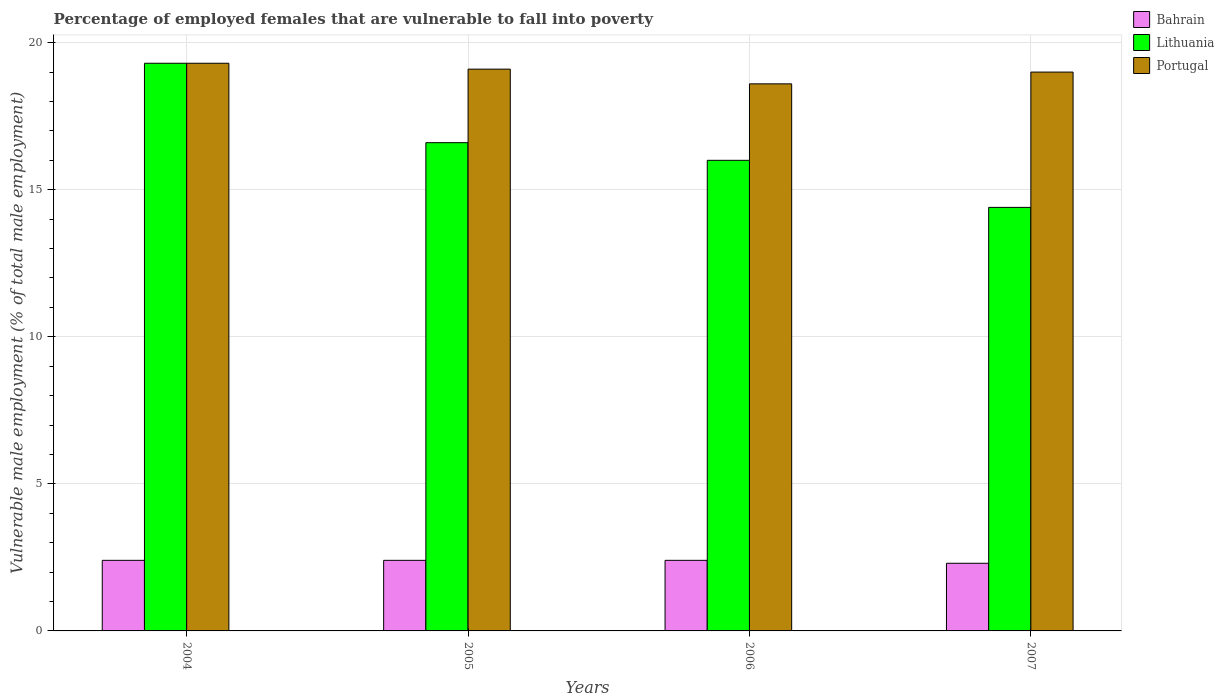How many different coloured bars are there?
Keep it short and to the point. 3. How many groups of bars are there?
Offer a very short reply. 4. Are the number of bars on each tick of the X-axis equal?
Your response must be concise. Yes. How many bars are there on the 2nd tick from the left?
Keep it short and to the point. 3. How many bars are there on the 1st tick from the right?
Provide a short and direct response. 3. What is the label of the 1st group of bars from the left?
Offer a terse response. 2004. In how many cases, is the number of bars for a given year not equal to the number of legend labels?
Your answer should be very brief. 0. What is the percentage of employed females who are vulnerable to fall into poverty in Lithuania in 2004?
Your answer should be compact. 19.3. Across all years, what is the maximum percentage of employed females who are vulnerable to fall into poverty in Lithuania?
Your response must be concise. 19.3. Across all years, what is the minimum percentage of employed females who are vulnerable to fall into poverty in Lithuania?
Ensure brevity in your answer.  14.4. In which year was the percentage of employed females who are vulnerable to fall into poverty in Portugal maximum?
Ensure brevity in your answer.  2004. What is the total percentage of employed females who are vulnerable to fall into poverty in Portugal in the graph?
Your answer should be very brief. 76. What is the difference between the percentage of employed females who are vulnerable to fall into poverty in Portugal in 2005 and that in 2007?
Your answer should be compact. 0.1. What is the difference between the percentage of employed females who are vulnerable to fall into poverty in Portugal in 2007 and the percentage of employed females who are vulnerable to fall into poverty in Lithuania in 2004?
Provide a succinct answer. -0.3. What is the average percentage of employed females who are vulnerable to fall into poverty in Portugal per year?
Ensure brevity in your answer.  19. What is the ratio of the percentage of employed females who are vulnerable to fall into poverty in Bahrain in 2004 to that in 2007?
Provide a succinct answer. 1.04. Is the difference between the percentage of employed females who are vulnerable to fall into poverty in Portugal in 2004 and 2007 greater than the difference between the percentage of employed females who are vulnerable to fall into poverty in Lithuania in 2004 and 2007?
Keep it short and to the point. No. What is the difference between the highest and the second highest percentage of employed females who are vulnerable to fall into poverty in Portugal?
Provide a succinct answer. 0.2. What is the difference between the highest and the lowest percentage of employed females who are vulnerable to fall into poverty in Bahrain?
Offer a very short reply. 0.1. In how many years, is the percentage of employed females who are vulnerable to fall into poverty in Bahrain greater than the average percentage of employed females who are vulnerable to fall into poverty in Bahrain taken over all years?
Your response must be concise. 3. What does the 2nd bar from the right in 2004 represents?
Offer a very short reply. Lithuania. Is it the case that in every year, the sum of the percentage of employed females who are vulnerable to fall into poverty in Bahrain and percentage of employed females who are vulnerable to fall into poverty in Lithuania is greater than the percentage of employed females who are vulnerable to fall into poverty in Portugal?
Offer a terse response. No. Are all the bars in the graph horizontal?
Ensure brevity in your answer.  No. How many years are there in the graph?
Offer a terse response. 4. What is the difference between two consecutive major ticks on the Y-axis?
Provide a short and direct response. 5. Are the values on the major ticks of Y-axis written in scientific E-notation?
Give a very brief answer. No. Does the graph contain any zero values?
Provide a short and direct response. No. Does the graph contain grids?
Provide a succinct answer. Yes. Where does the legend appear in the graph?
Provide a short and direct response. Top right. How many legend labels are there?
Offer a terse response. 3. How are the legend labels stacked?
Provide a succinct answer. Vertical. What is the title of the graph?
Provide a short and direct response. Percentage of employed females that are vulnerable to fall into poverty. Does "Australia" appear as one of the legend labels in the graph?
Ensure brevity in your answer.  No. What is the label or title of the X-axis?
Ensure brevity in your answer.  Years. What is the label or title of the Y-axis?
Keep it short and to the point. Vulnerable male employment (% of total male employment). What is the Vulnerable male employment (% of total male employment) of Bahrain in 2004?
Offer a very short reply. 2.4. What is the Vulnerable male employment (% of total male employment) of Lithuania in 2004?
Your answer should be very brief. 19.3. What is the Vulnerable male employment (% of total male employment) in Portugal in 2004?
Your answer should be very brief. 19.3. What is the Vulnerable male employment (% of total male employment) in Bahrain in 2005?
Ensure brevity in your answer.  2.4. What is the Vulnerable male employment (% of total male employment) of Lithuania in 2005?
Your response must be concise. 16.6. What is the Vulnerable male employment (% of total male employment) of Portugal in 2005?
Make the answer very short. 19.1. What is the Vulnerable male employment (% of total male employment) of Bahrain in 2006?
Offer a terse response. 2.4. What is the Vulnerable male employment (% of total male employment) of Portugal in 2006?
Your answer should be compact. 18.6. What is the Vulnerable male employment (% of total male employment) in Bahrain in 2007?
Your answer should be compact. 2.3. What is the Vulnerable male employment (% of total male employment) of Lithuania in 2007?
Your response must be concise. 14.4. Across all years, what is the maximum Vulnerable male employment (% of total male employment) of Bahrain?
Ensure brevity in your answer.  2.4. Across all years, what is the maximum Vulnerable male employment (% of total male employment) in Lithuania?
Provide a succinct answer. 19.3. Across all years, what is the maximum Vulnerable male employment (% of total male employment) of Portugal?
Your answer should be very brief. 19.3. Across all years, what is the minimum Vulnerable male employment (% of total male employment) in Bahrain?
Give a very brief answer. 2.3. Across all years, what is the minimum Vulnerable male employment (% of total male employment) in Lithuania?
Provide a short and direct response. 14.4. Across all years, what is the minimum Vulnerable male employment (% of total male employment) of Portugal?
Provide a succinct answer. 18.6. What is the total Vulnerable male employment (% of total male employment) in Bahrain in the graph?
Offer a very short reply. 9.5. What is the total Vulnerable male employment (% of total male employment) of Lithuania in the graph?
Offer a very short reply. 66.3. What is the total Vulnerable male employment (% of total male employment) in Portugal in the graph?
Provide a short and direct response. 76. What is the difference between the Vulnerable male employment (% of total male employment) of Portugal in 2004 and that in 2005?
Keep it short and to the point. 0.2. What is the difference between the Vulnerable male employment (% of total male employment) in Bahrain in 2004 and that in 2006?
Offer a very short reply. 0. What is the difference between the Vulnerable male employment (% of total male employment) of Portugal in 2004 and that in 2006?
Provide a succinct answer. 0.7. What is the difference between the Vulnerable male employment (% of total male employment) in Bahrain in 2004 and that in 2007?
Offer a very short reply. 0.1. What is the difference between the Vulnerable male employment (% of total male employment) in Portugal in 2004 and that in 2007?
Your answer should be very brief. 0.3. What is the difference between the Vulnerable male employment (% of total male employment) of Bahrain in 2005 and that in 2007?
Offer a very short reply. 0.1. What is the difference between the Vulnerable male employment (% of total male employment) in Bahrain in 2004 and the Vulnerable male employment (% of total male employment) in Lithuania in 2005?
Provide a succinct answer. -14.2. What is the difference between the Vulnerable male employment (% of total male employment) of Bahrain in 2004 and the Vulnerable male employment (% of total male employment) of Portugal in 2005?
Provide a short and direct response. -16.7. What is the difference between the Vulnerable male employment (% of total male employment) of Bahrain in 2004 and the Vulnerable male employment (% of total male employment) of Lithuania in 2006?
Provide a succinct answer. -13.6. What is the difference between the Vulnerable male employment (% of total male employment) in Bahrain in 2004 and the Vulnerable male employment (% of total male employment) in Portugal in 2006?
Your answer should be compact. -16.2. What is the difference between the Vulnerable male employment (% of total male employment) of Bahrain in 2004 and the Vulnerable male employment (% of total male employment) of Portugal in 2007?
Your response must be concise. -16.6. What is the difference between the Vulnerable male employment (% of total male employment) in Bahrain in 2005 and the Vulnerable male employment (% of total male employment) in Portugal in 2006?
Keep it short and to the point. -16.2. What is the difference between the Vulnerable male employment (% of total male employment) in Lithuania in 2005 and the Vulnerable male employment (% of total male employment) in Portugal in 2006?
Your answer should be compact. -2. What is the difference between the Vulnerable male employment (% of total male employment) of Bahrain in 2005 and the Vulnerable male employment (% of total male employment) of Portugal in 2007?
Keep it short and to the point. -16.6. What is the difference between the Vulnerable male employment (% of total male employment) in Bahrain in 2006 and the Vulnerable male employment (% of total male employment) in Lithuania in 2007?
Offer a terse response. -12. What is the difference between the Vulnerable male employment (% of total male employment) in Bahrain in 2006 and the Vulnerable male employment (% of total male employment) in Portugal in 2007?
Your response must be concise. -16.6. What is the average Vulnerable male employment (% of total male employment) in Bahrain per year?
Provide a succinct answer. 2.38. What is the average Vulnerable male employment (% of total male employment) in Lithuania per year?
Provide a succinct answer. 16.57. In the year 2004, what is the difference between the Vulnerable male employment (% of total male employment) in Bahrain and Vulnerable male employment (% of total male employment) in Lithuania?
Make the answer very short. -16.9. In the year 2004, what is the difference between the Vulnerable male employment (% of total male employment) in Bahrain and Vulnerable male employment (% of total male employment) in Portugal?
Provide a short and direct response. -16.9. In the year 2004, what is the difference between the Vulnerable male employment (% of total male employment) in Lithuania and Vulnerable male employment (% of total male employment) in Portugal?
Provide a succinct answer. 0. In the year 2005, what is the difference between the Vulnerable male employment (% of total male employment) of Bahrain and Vulnerable male employment (% of total male employment) of Portugal?
Provide a succinct answer. -16.7. In the year 2005, what is the difference between the Vulnerable male employment (% of total male employment) in Lithuania and Vulnerable male employment (% of total male employment) in Portugal?
Your answer should be very brief. -2.5. In the year 2006, what is the difference between the Vulnerable male employment (% of total male employment) of Bahrain and Vulnerable male employment (% of total male employment) of Lithuania?
Your answer should be very brief. -13.6. In the year 2006, what is the difference between the Vulnerable male employment (% of total male employment) of Bahrain and Vulnerable male employment (% of total male employment) of Portugal?
Offer a very short reply. -16.2. In the year 2006, what is the difference between the Vulnerable male employment (% of total male employment) of Lithuania and Vulnerable male employment (% of total male employment) of Portugal?
Provide a short and direct response. -2.6. In the year 2007, what is the difference between the Vulnerable male employment (% of total male employment) of Bahrain and Vulnerable male employment (% of total male employment) of Portugal?
Make the answer very short. -16.7. In the year 2007, what is the difference between the Vulnerable male employment (% of total male employment) of Lithuania and Vulnerable male employment (% of total male employment) of Portugal?
Give a very brief answer. -4.6. What is the ratio of the Vulnerable male employment (% of total male employment) in Lithuania in 2004 to that in 2005?
Provide a short and direct response. 1.16. What is the ratio of the Vulnerable male employment (% of total male employment) in Portugal in 2004 to that in 2005?
Provide a short and direct response. 1.01. What is the ratio of the Vulnerable male employment (% of total male employment) in Lithuania in 2004 to that in 2006?
Your answer should be very brief. 1.21. What is the ratio of the Vulnerable male employment (% of total male employment) in Portugal in 2004 to that in 2006?
Offer a very short reply. 1.04. What is the ratio of the Vulnerable male employment (% of total male employment) in Bahrain in 2004 to that in 2007?
Provide a succinct answer. 1.04. What is the ratio of the Vulnerable male employment (% of total male employment) in Lithuania in 2004 to that in 2007?
Provide a succinct answer. 1.34. What is the ratio of the Vulnerable male employment (% of total male employment) in Portugal in 2004 to that in 2007?
Offer a terse response. 1.02. What is the ratio of the Vulnerable male employment (% of total male employment) of Bahrain in 2005 to that in 2006?
Your answer should be very brief. 1. What is the ratio of the Vulnerable male employment (% of total male employment) of Lithuania in 2005 to that in 2006?
Your answer should be very brief. 1.04. What is the ratio of the Vulnerable male employment (% of total male employment) in Portugal in 2005 to that in 2006?
Make the answer very short. 1.03. What is the ratio of the Vulnerable male employment (% of total male employment) in Bahrain in 2005 to that in 2007?
Your answer should be very brief. 1.04. What is the ratio of the Vulnerable male employment (% of total male employment) of Lithuania in 2005 to that in 2007?
Keep it short and to the point. 1.15. What is the ratio of the Vulnerable male employment (% of total male employment) of Bahrain in 2006 to that in 2007?
Make the answer very short. 1.04. What is the ratio of the Vulnerable male employment (% of total male employment) in Portugal in 2006 to that in 2007?
Provide a short and direct response. 0.98. What is the difference between the highest and the second highest Vulnerable male employment (% of total male employment) of Bahrain?
Offer a very short reply. 0. What is the difference between the highest and the second highest Vulnerable male employment (% of total male employment) in Portugal?
Your answer should be very brief. 0.2. What is the difference between the highest and the lowest Vulnerable male employment (% of total male employment) of Bahrain?
Offer a terse response. 0.1. 